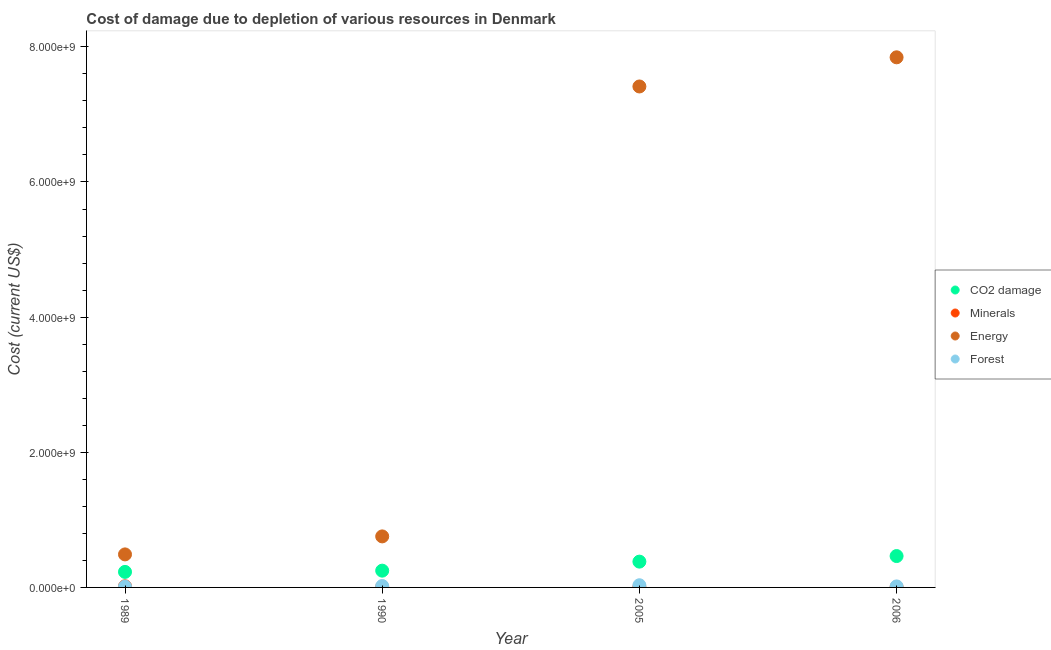What is the cost of damage due to depletion of coal in 1990?
Make the answer very short. 2.48e+08. Across all years, what is the maximum cost of damage due to depletion of forests?
Give a very brief answer. 3.23e+07. Across all years, what is the minimum cost of damage due to depletion of forests?
Your answer should be very brief. 1.32e+07. In which year was the cost of damage due to depletion of energy minimum?
Offer a very short reply. 1989. What is the total cost of damage due to depletion of minerals in the graph?
Keep it short and to the point. 3.28e+07. What is the difference between the cost of damage due to depletion of forests in 2005 and that in 2006?
Keep it short and to the point. 1.71e+07. What is the difference between the cost of damage due to depletion of forests in 1989 and the cost of damage due to depletion of minerals in 2006?
Provide a short and direct response. 8.40e+06. What is the average cost of damage due to depletion of coal per year?
Your answer should be compact. 3.31e+08. In the year 2006, what is the difference between the cost of damage due to depletion of energy and cost of damage due to depletion of forests?
Your answer should be compact. 7.83e+09. In how many years, is the cost of damage due to depletion of coal greater than 2000000000 US$?
Provide a succinct answer. 0. What is the ratio of the cost of damage due to depletion of energy in 1989 to that in 2005?
Your answer should be very brief. 0.07. What is the difference between the highest and the second highest cost of damage due to depletion of energy?
Provide a short and direct response. 4.32e+08. What is the difference between the highest and the lowest cost of damage due to depletion of forests?
Provide a succinct answer. 1.92e+07. Is it the case that in every year, the sum of the cost of damage due to depletion of energy and cost of damage due to depletion of coal is greater than the sum of cost of damage due to depletion of minerals and cost of damage due to depletion of forests?
Provide a succinct answer. Yes. Is it the case that in every year, the sum of the cost of damage due to depletion of coal and cost of damage due to depletion of minerals is greater than the cost of damage due to depletion of energy?
Offer a very short reply. No. How many dotlines are there?
Offer a very short reply. 4. How many years are there in the graph?
Make the answer very short. 4. What is the difference between two consecutive major ticks on the Y-axis?
Your answer should be very brief. 2.00e+09. Are the values on the major ticks of Y-axis written in scientific E-notation?
Offer a terse response. Yes. Does the graph contain any zero values?
Your response must be concise. No. How are the legend labels stacked?
Give a very brief answer. Vertical. What is the title of the graph?
Provide a succinct answer. Cost of damage due to depletion of various resources in Denmark . What is the label or title of the X-axis?
Keep it short and to the point. Year. What is the label or title of the Y-axis?
Give a very brief answer. Cost (current US$). What is the Cost (current US$) of CO2 damage in 1989?
Ensure brevity in your answer.  2.30e+08. What is the Cost (current US$) of Minerals in 1989?
Offer a very short reply. 1.68e+07. What is the Cost (current US$) of Energy in 1989?
Keep it short and to the point. 4.89e+08. What is the Cost (current US$) in Forest in 1989?
Make the answer very short. 1.32e+07. What is the Cost (current US$) in CO2 damage in 1990?
Your answer should be very brief. 2.48e+08. What is the Cost (current US$) of Minerals in 1990?
Offer a terse response. 6.54e+06. What is the Cost (current US$) in Energy in 1990?
Keep it short and to the point. 7.55e+08. What is the Cost (current US$) of Forest in 1990?
Your answer should be very brief. 2.11e+07. What is the Cost (current US$) in CO2 damage in 2005?
Give a very brief answer. 3.82e+08. What is the Cost (current US$) in Minerals in 2005?
Your response must be concise. 4.71e+06. What is the Cost (current US$) of Energy in 2005?
Your answer should be very brief. 7.41e+09. What is the Cost (current US$) in Forest in 2005?
Provide a short and direct response. 3.23e+07. What is the Cost (current US$) of CO2 damage in 2006?
Offer a terse response. 4.64e+08. What is the Cost (current US$) of Minerals in 2006?
Your response must be concise. 4.75e+06. What is the Cost (current US$) of Energy in 2006?
Make the answer very short. 7.84e+09. What is the Cost (current US$) of Forest in 2006?
Provide a succinct answer. 1.52e+07. Across all years, what is the maximum Cost (current US$) in CO2 damage?
Make the answer very short. 4.64e+08. Across all years, what is the maximum Cost (current US$) in Minerals?
Provide a short and direct response. 1.68e+07. Across all years, what is the maximum Cost (current US$) of Energy?
Offer a very short reply. 7.84e+09. Across all years, what is the maximum Cost (current US$) of Forest?
Offer a terse response. 3.23e+07. Across all years, what is the minimum Cost (current US$) in CO2 damage?
Offer a very short reply. 2.30e+08. Across all years, what is the minimum Cost (current US$) in Minerals?
Offer a terse response. 4.71e+06. Across all years, what is the minimum Cost (current US$) of Energy?
Provide a succinct answer. 4.89e+08. Across all years, what is the minimum Cost (current US$) in Forest?
Offer a very short reply. 1.32e+07. What is the total Cost (current US$) in CO2 damage in the graph?
Your answer should be very brief. 1.32e+09. What is the total Cost (current US$) of Minerals in the graph?
Offer a very short reply. 3.28e+07. What is the total Cost (current US$) of Energy in the graph?
Make the answer very short. 1.65e+1. What is the total Cost (current US$) of Forest in the graph?
Offer a terse response. 8.18e+07. What is the difference between the Cost (current US$) of CO2 damage in 1989 and that in 1990?
Offer a very short reply. -1.84e+07. What is the difference between the Cost (current US$) in Minerals in 1989 and that in 1990?
Make the answer very short. 1.02e+07. What is the difference between the Cost (current US$) in Energy in 1989 and that in 1990?
Provide a short and direct response. -2.66e+08. What is the difference between the Cost (current US$) of Forest in 1989 and that in 1990?
Make the answer very short. -7.95e+06. What is the difference between the Cost (current US$) of CO2 damage in 1989 and that in 2005?
Make the answer very short. -1.52e+08. What is the difference between the Cost (current US$) of Minerals in 1989 and that in 2005?
Your answer should be very brief. 1.21e+07. What is the difference between the Cost (current US$) of Energy in 1989 and that in 2005?
Keep it short and to the point. -6.92e+09. What is the difference between the Cost (current US$) in Forest in 1989 and that in 2005?
Ensure brevity in your answer.  -1.92e+07. What is the difference between the Cost (current US$) of CO2 damage in 1989 and that in 2006?
Provide a short and direct response. -2.34e+08. What is the difference between the Cost (current US$) in Minerals in 1989 and that in 2006?
Offer a very short reply. 1.20e+07. What is the difference between the Cost (current US$) of Energy in 1989 and that in 2006?
Offer a very short reply. -7.36e+09. What is the difference between the Cost (current US$) of Forest in 1989 and that in 2006?
Your response must be concise. -2.06e+06. What is the difference between the Cost (current US$) of CO2 damage in 1990 and that in 2005?
Your response must be concise. -1.34e+08. What is the difference between the Cost (current US$) in Minerals in 1990 and that in 2005?
Your response must be concise. 1.83e+06. What is the difference between the Cost (current US$) of Energy in 1990 and that in 2005?
Give a very brief answer. -6.66e+09. What is the difference between the Cost (current US$) in Forest in 1990 and that in 2005?
Offer a terse response. -1.12e+07. What is the difference between the Cost (current US$) of CO2 damage in 1990 and that in 2006?
Provide a short and direct response. -2.16e+08. What is the difference between the Cost (current US$) in Minerals in 1990 and that in 2006?
Provide a short and direct response. 1.79e+06. What is the difference between the Cost (current US$) in Energy in 1990 and that in 2006?
Give a very brief answer. -7.09e+09. What is the difference between the Cost (current US$) in Forest in 1990 and that in 2006?
Your response must be concise. 5.90e+06. What is the difference between the Cost (current US$) of CO2 damage in 2005 and that in 2006?
Give a very brief answer. -8.25e+07. What is the difference between the Cost (current US$) of Minerals in 2005 and that in 2006?
Your answer should be very brief. -4.00e+04. What is the difference between the Cost (current US$) of Energy in 2005 and that in 2006?
Your answer should be compact. -4.32e+08. What is the difference between the Cost (current US$) of Forest in 2005 and that in 2006?
Ensure brevity in your answer.  1.71e+07. What is the difference between the Cost (current US$) of CO2 damage in 1989 and the Cost (current US$) of Minerals in 1990?
Keep it short and to the point. 2.23e+08. What is the difference between the Cost (current US$) in CO2 damage in 1989 and the Cost (current US$) in Energy in 1990?
Offer a terse response. -5.25e+08. What is the difference between the Cost (current US$) in CO2 damage in 1989 and the Cost (current US$) in Forest in 1990?
Your response must be concise. 2.09e+08. What is the difference between the Cost (current US$) in Minerals in 1989 and the Cost (current US$) in Energy in 1990?
Offer a terse response. -7.38e+08. What is the difference between the Cost (current US$) of Minerals in 1989 and the Cost (current US$) of Forest in 1990?
Provide a short and direct response. -4.32e+06. What is the difference between the Cost (current US$) in Energy in 1989 and the Cost (current US$) in Forest in 1990?
Keep it short and to the point. 4.68e+08. What is the difference between the Cost (current US$) in CO2 damage in 1989 and the Cost (current US$) in Minerals in 2005?
Give a very brief answer. 2.25e+08. What is the difference between the Cost (current US$) in CO2 damage in 1989 and the Cost (current US$) in Energy in 2005?
Ensure brevity in your answer.  -7.18e+09. What is the difference between the Cost (current US$) in CO2 damage in 1989 and the Cost (current US$) in Forest in 2005?
Keep it short and to the point. 1.97e+08. What is the difference between the Cost (current US$) of Minerals in 1989 and the Cost (current US$) of Energy in 2005?
Your response must be concise. -7.40e+09. What is the difference between the Cost (current US$) of Minerals in 1989 and the Cost (current US$) of Forest in 2005?
Offer a terse response. -1.56e+07. What is the difference between the Cost (current US$) in Energy in 1989 and the Cost (current US$) in Forest in 2005?
Your response must be concise. 4.56e+08. What is the difference between the Cost (current US$) in CO2 damage in 1989 and the Cost (current US$) in Minerals in 2006?
Provide a short and direct response. 2.25e+08. What is the difference between the Cost (current US$) of CO2 damage in 1989 and the Cost (current US$) of Energy in 2006?
Your response must be concise. -7.62e+09. What is the difference between the Cost (current US$) of CO2 damage in 1989 and the Cost (current US$) of Forest in 2006?
Ensure brevity in your answer.  2.15e+08. What is the difference between the Cost (current US$) of Minerals in 1989 and the Cost (current US$) of Energy in 2006?
Give a very brief answer. -7.83e+09. What is the difference between the Cost (current US$) in Minerals in 1989 and the Cost (current US$) in Forest in 2006?
Your answer should be compact. 1.57e+06. What is the difference between the Cost (current US$) in Energy in 1989 and the Cost (current US$) in Forest in 2006?
Keep it short and to the point. 4.74e+08. What is the difference between the Cost (current US$) in CO2 damage in 1990 and the Cost (current US$) in Minerals in 2005?
Provide a short and direct response. 2.43e+08. What is the difference between the Cost (current US$) of CO2 damage in 1990 and the Cost (current US$) of Energy in 2005?
Keep it short and to the point. -7.17e+09. What is the difference between the Cost (current US$) in CO2 damage in 1990 and the Cost (current US$) in Forest in 2005?
Keep it short and to the point. 2.16e+08. What is the difference between the Cost (current US$) in Minerals in 1990 and the Cost (current US$) in Energy in 2005?
Provide a succinct answer. -7.41e+09. What is the difference between the Cost (current US$) in Minerals in 1990 and the Cost (current US$) in Forest in 2005?
Make the answer very short. -2.58e+07. What is the difference between the Cost (current US$) of Energy in 1990 and the Cost (current US$) of Forest in 2005?
Ensure brevity in your answer.  7.23e+08. What is the difference between the Cost (current US$) in CO2 damage in 1990 and the Cost (current US$) in Minerals in 2006?
Your answer should be compact. 2.43e+08. What is the difference between the Cost (current US$) in CO2 damage in 1990 and the Cost (current US$) in Energy in 2006?
Offer a very short reply. -7.60e+09. What is the difference between the Cost (current US$) of CO2 damage in 1990 and the Cost (current US$) of Forest in 2006?
Your answer should be compact. 2.33e+08. What is the difference between the Cost (current US$) in Minerals in 1990 and the Cost (current US$) in Energy in 2006?
Give a very brief answer. -7.84e+09. What is the difference between the Cost (current US$) of Minerals in 1990 and the Cost (current US$) of Forest in 2006?
Your response must be concise. -8.67e+06. What is the difference between the Cost (current US$) of Energy in 1990 and the Cost (current US$) of Forest in 2006?
Your answer should be very brief. 7.40e+08. What is the difference between the Cost (current US$) of CO2 damage in 2005 and the Cost (current US$) of Minerals in 2006?
Provide a short and direct response. 3.77e+08. What is the difference between the Cost (current US$) of CO2 damage in 2005 and the Cost (current US$) of Energy in 2006?
Offer a very short reply. -7.46e+09. What is the difference between the Cost (current US$) in CO2 damage in 2005 and the Cost (current US$) in Forest in 2006?
Provide a short and direct response. 3.67e+08. What is the difference between the Cost (current US$) in Minerals in 2005 and the Cost (current US$) in Energy in 2006?
Offer a very short reply. -7.84e+09. What is the difference between the Cost (current US$) of Minerals in 2005 and the Cost (current US$) of Forest in 2006?
Your response must be concise. -1.05e+07. What is the difference between the Cost (current US$) in Energy in 2005 and the Cost (current US$) in Forest in 2006?
Offer a very short reply. 7.40e+09. What is the average Cost (current US$) of CO2 damage per year?
Offer a very short reply. 3.31e+08. What is the average Cost (current US$) of Minerals per year?
Make the answer very short. 8.20e+06. What is the average Cost (current US$) of Energy per year?
Make the answer very short. 4.13e+09. What is the average Cost (current US$) of Forest per year?
Offer a very short reply. 2.05e+07. In the year 1989, what is the difference between the Cost (current US$) of CO2 damage and Cost (current US$) of Minerals?
Offer a very short reply. 2.13e+08. In the year 1989, what is the difference between the Cost (current US$) of CO2 damage and Cost (current US$) of Energy?
Provide a succinct answer. -2.59e+08. In the year 1989, what is the difference between the Cost (current US$) of CO2 damage and Cost (current US$) of Forest?
Ensure brevity in your answer.  2.17e+08. In the year 1989, what is the difference between the Cost (current US$) in Minerals and Cost (current US$) in Energy?
Ensure brevity in your answer.  -4.72e+08. In the year 1989, what is the difference between the Cost (current US$) of Minerals and Cost (current US$) of Forest?
Provide a succinct answer. 3.63e+06. In the year 1989, what is the difference between the Cost (current US$) of Energy and Cost (current US$) of Forest?
Keep it short and to the point. 4.76e+08. In the year 1990, what is the difference between the Cost (current US$) of CO2 damage and Cost (current US$) of Minerals?
Your response must be concise. 2.42e+08. In the year 1990, what is the difference between the Cost (current US$) in CO2 damage and Cost (current US$) in Energy?
Your response must be concise. -5.07e+08. In the year 1990, what is the difference between the Cost (current US$) in CO2 damage and Cost (current US$) in Forest?
Offer a very short reply. 2.27e+08. In the year 1990, what is the difference between the Cost (current US$) of Minerals and Cost (current US$) of Energy?
Make the answer very short. -7.49e+08. In the year 1990, what is the difference between the Cost (current US$) in Minerals and Cost (current US$) in Forest?
Offer a very short reply. -1.46e+07. In the year 1990, what is the difference between the Cost (current US$) of Energy and Cost (current US$) of Forest?
Give a very brief answer. 7.34e+08. In the year 2005, what is the difference between the Cost (current US$) in CO2 damage and Cost (current US$) in Minerals?
Provide a short and direct response. 3.77e+08. In the year 2005, what is the difference between the Cost (current US$) in CO2 damage and Cost (current US$) in Energy?
Your answer should be very brief. -7.03e+09. In the year 2005, what is the difference between the Cost (current US$) of CO2 damage and Cost (current US$) of Forest?
Ensure brevity in your answer.  3.49e+08. In the year 2005, what is the difference between the Cost (current US$) of Minerals and Cost (current US$) of Energy?
Keep it short and to the point. -7.41e+09. In the year 2005, what is the difference between the Cost (current US$) in Minerals and Cost (current US$) in Forest?
Offer a terse response. -2.76e+07. In the year 2005, what is the difference between the Cost (current US$) in Energy and Cost (current US$) in Forest?
Ensure brevity in your answer.  7.38e+09. In the year 2006, what is the difference between the Cost (current US$) of CO2 damage and Cost (current US$) of Minerals?
Offer a very short reply. 4.59e+08. In the year 2006, what is the difference between the Cost (current US$) in CO2 damage and Cost (current US$) in Energy?
Provide a short and direct response. -7.38e+09. In the year 2006, what is the difference between the Cost (current US$) of CO2 damage and Cost (current US$) of Forest?
Your answer should be very brief. 4.49e+08. In the year 2006, what is the difference between the Cost (current US$) in Minerals and Cost (current US$) in Energy?
Keep it short and to the point. -7.84e+09. In the year 2006, what is the difference between the Cost (current US$) of Minerals and Cost (current US$) of Forest?
Offer a very short reply. -1.05e+07. In the year 2006, what is the difference between the Cost (current US$) of Energy and Cost (current US$) of Forest?
Offer a very short reply. 7.83e+09. What is the ratio of the Cost (current US$) of CO2 damage in 1989 to that in 1990?
Provide a succinct answer. 0.93. What is the ratio of the Cost (current US$) in Minerals in 1989 to that in 1990?
Make the answer very short. 2.57. What is the ratio of the Cost (current US$) of Energy in 1989 to that in 1990?
Provide a succinct answer. 0.65. What is the ratio of the Cost (current US$) of Forest in 1989 to that in 1990?
Provide a short and direct response. 0.62. What is the ratio of the Cost (current US$) in CO2 damage in 1989 to that in 2005?
Your response must be concise. 0.6. What is the ratio of the Cost (current US$) in Minerals in 1989 to that in 2005?
Make the answer very short. 3.56. What is the ratio of the Cost (current US$) of Energy in 1989 to that in 2005?
Provide a short and direct response. 0.07. What is the ratio of the Cost (current US$) in Forest in 1989 to that in 2005?
Keep it short and to the point. 0.41. What is the ratio of the Cost (current US$) in CO2 damage in 1989 to that in 2006?
Provide a succinct answer. 0.49. What is the ratio of the Cost (current US$) in Minerals in 1989 to that in 2006?
Offer a very short reply. 3.53. What is the ratio of the Cost (current US$) of Energy in 1989 to that in 2006?
Your answer should be very brief. 0.06. What is the ratio of the Cost (current US$) of Forest in 1989 to that in 2006?
Make the answer very short. 0.86. What is the ratio of the Cost (current US$) of CO2 damage in 1990 to that in 2005?
Provide a short and direct response. 0.65. What is the ratio of the Cost (current US$) of Minerals in 1990 to that in 2005?
Your answer should be compact. 1.39. What is the ratio of the Cost (current US$) of Energy in 1990 to that in 2005?
Your answer should be very brief. 0.1. What is the ratio of the Cost (current US$) of Forest in 1990 to that in 2005?
Provide a short and direct response. 0.65. What is the ratio of the Cost (current US$) in CO2 damage in 1990 to that in 2006?
Your answer should be very brief. 0.53. What is the ratio of the Cost (current US$) in Minerals in 1990 to that in 2006?
Your answer should be compact. 1.38. What is the ratio of the Cost (current US$) in Energy in 1990 to that in 2006?
Your answer should be very brief. 0.1. What is the ratio of the Cost (current US$) in Forest in 1990 to that in 2006?
Ensure brevity in your answer.  1.39. What is the ratio of the Cost (current US$) in CO2 damage in 2005 to that in 2006?
Ensure brevity in your answer.  0.82. What is the ratio of the Cost (current US$) in Minerals in 2005 to that in 2006?
Your answer should be very brief. 0.99. What is the ratio of the Cost (current US$) in Energy in 2005 to that in 2006?
Provide a short and direct response. 0.94. What is the ratio of the Cost (current US$) of Forest in 2005 to that in 2006?
Provide a short and direct response. 2.13. What is the difference between the highest and the second highest Cost (current US$) of CO2 damage?
Make the answer very short. 8.25e+07. What is the difference between the highest and the second highest Cost (current US$) in Minerals?
Give a very brief answer. 1.02e+07. What is the difference between the highest and the second highest Cost (current US$) in Energy?
Your answer should be very brief. 4.32e+08. What is the difference between the highest and the second highest Cost (current US$) of Forest?
Your response must be concise. 1.12e+07. What is the difference between the highest and the lowest Cost (current US$) of CO2 damage?
Your response must be concise. 2.34e+08. What is the difference between the highest and the lowest Cost (current US$) of Minerals?
Make the answer very short. 1.21e+07. What is the difference between the highest and the lowest Cost (current US$) of Energy?
Make the answer very short. 7.36e+09. What is the difference between the highest and the lowest Cost (current US$) in Forest?
Your response must be concise. 1.92e+07. 